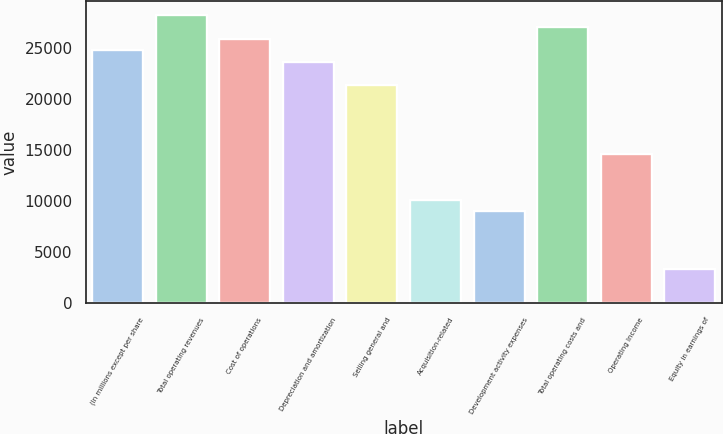Convert chart. <chart><loc_0><loc_0><loc_500><loc_500><bar_chart><fcel>(In millions except per share<fcel>Total operating revenues<fcel>Cost of operations<fcel>Depreciation and amortization<fcel>Selling general and<fcel>Acquisition-related<fcel>Development activity expenses<fcel>Total operating costs and<fcel>Operating Income<fcel>Equity in earnings of<nl><fcel>24848.5<fcel>28236.8<fcel>25977.9<fcel>23719<fcel>21460.1<fcel>10165.6<fcel>9036.1<fcel>27107.4<fcel>14683.4<fcel>3388.82<nl></chart> 